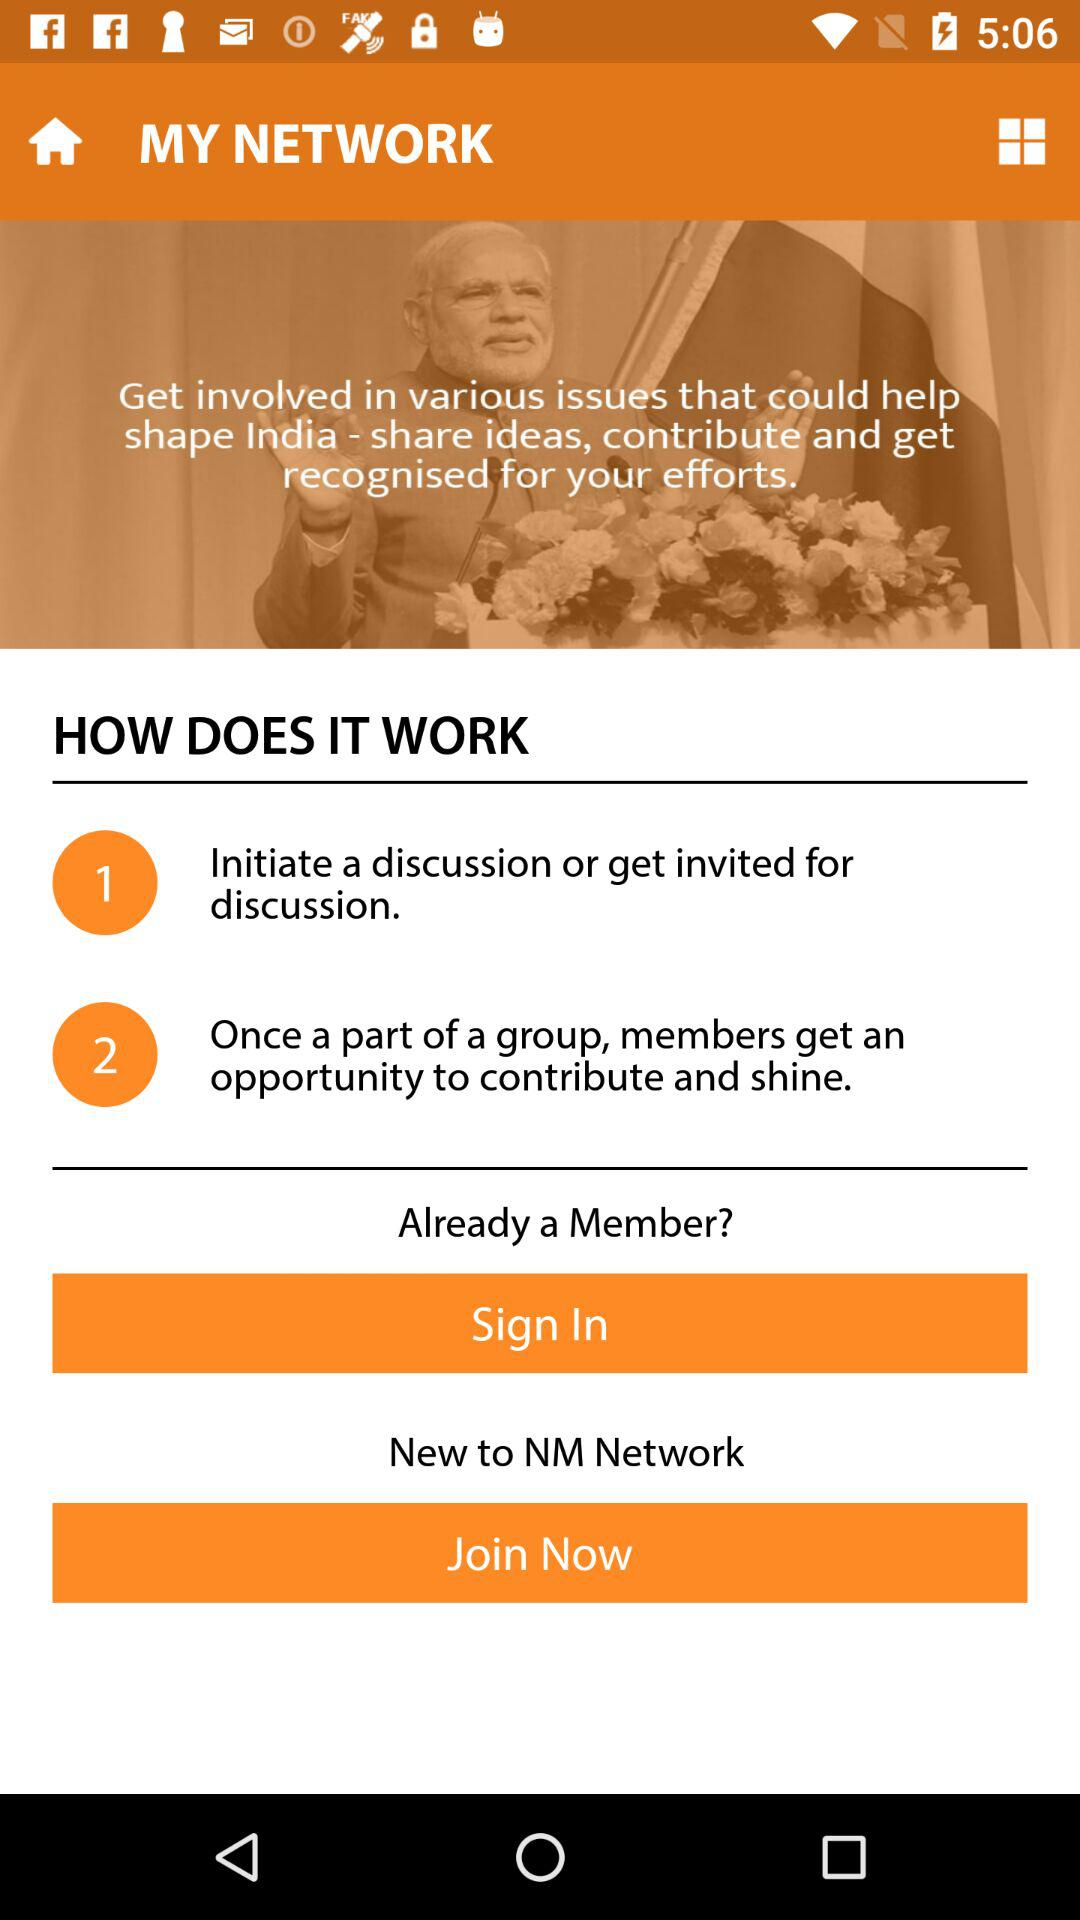What is the name of the application? The name of the application is "NM Network". 